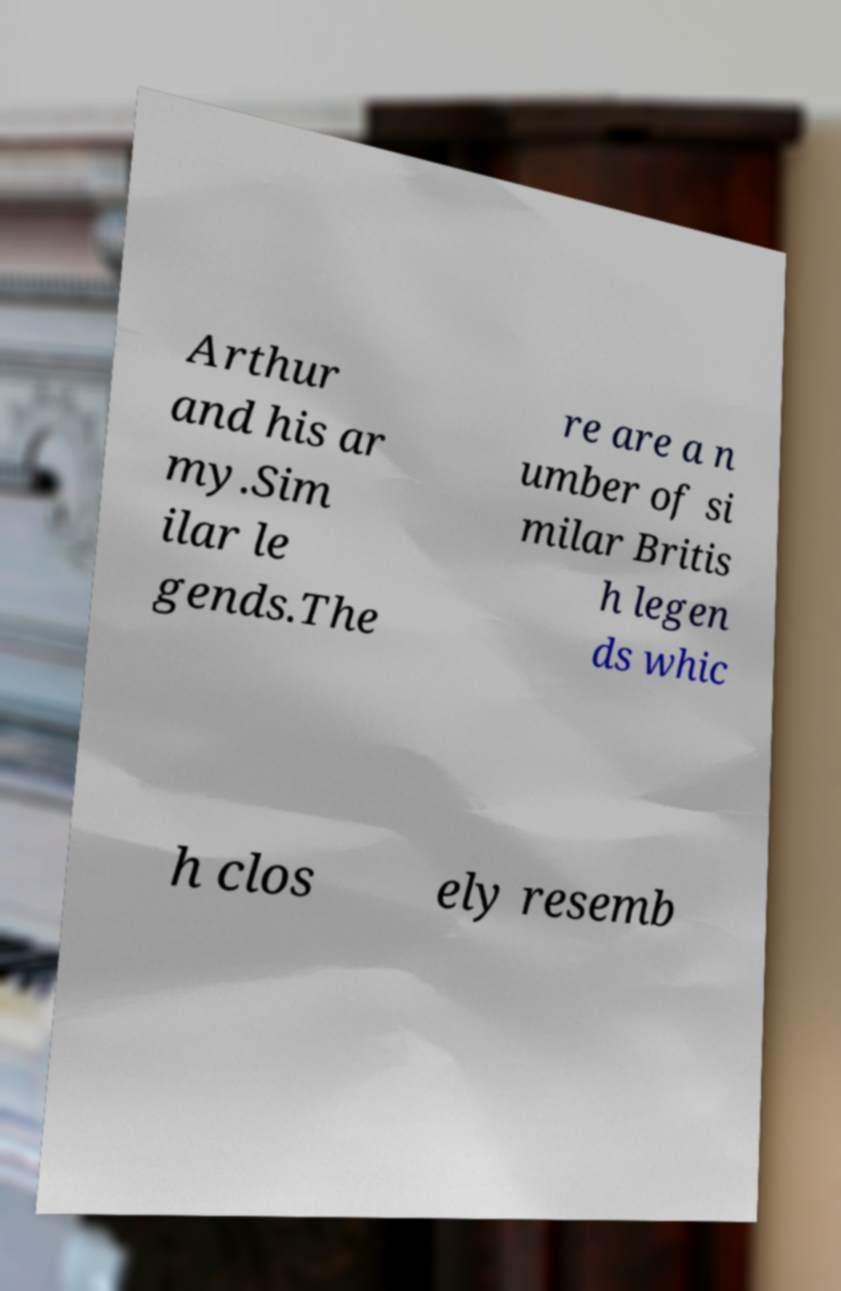I need the written content from this picture converted into text. Can you do that? Arthur and his ar my.Sim ilar le gends.The re are a n umber of si milar Britis h legen ds whic h clos ely resemb 